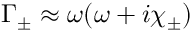Convert formula to latex. <formula><loc_0><loc_0><loc_500><loc_500>\Gamma _ { \pm } \approx \omega ( \omega + i \chi _ { \pm } )</formula> 